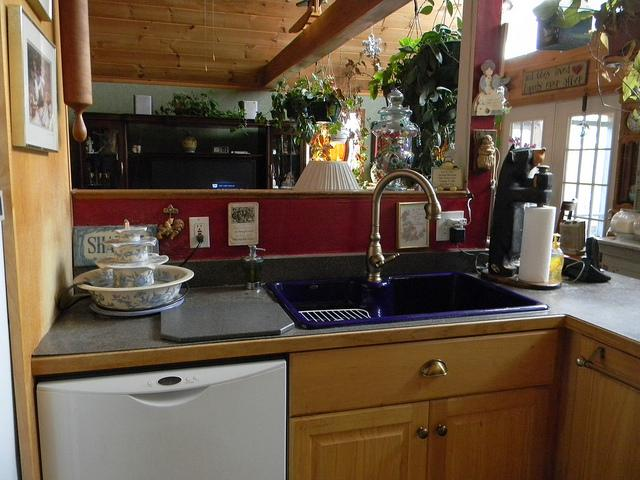What is on top of the counter?

Choices:
A) banana
B) sink
C) cat
D) television sink 